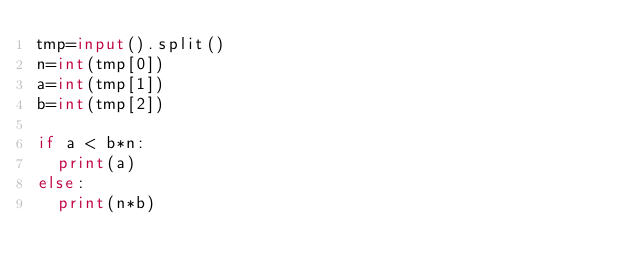<code> <loc_0><loc_0><loc_500><loc_500><_Python_>tmp=input().split()
n=int(tmp[0])
a=int(tmp[1])
b=int(tmp[2])

if a < b*n:
  print(a)
else:
  print(n*b)</code> 